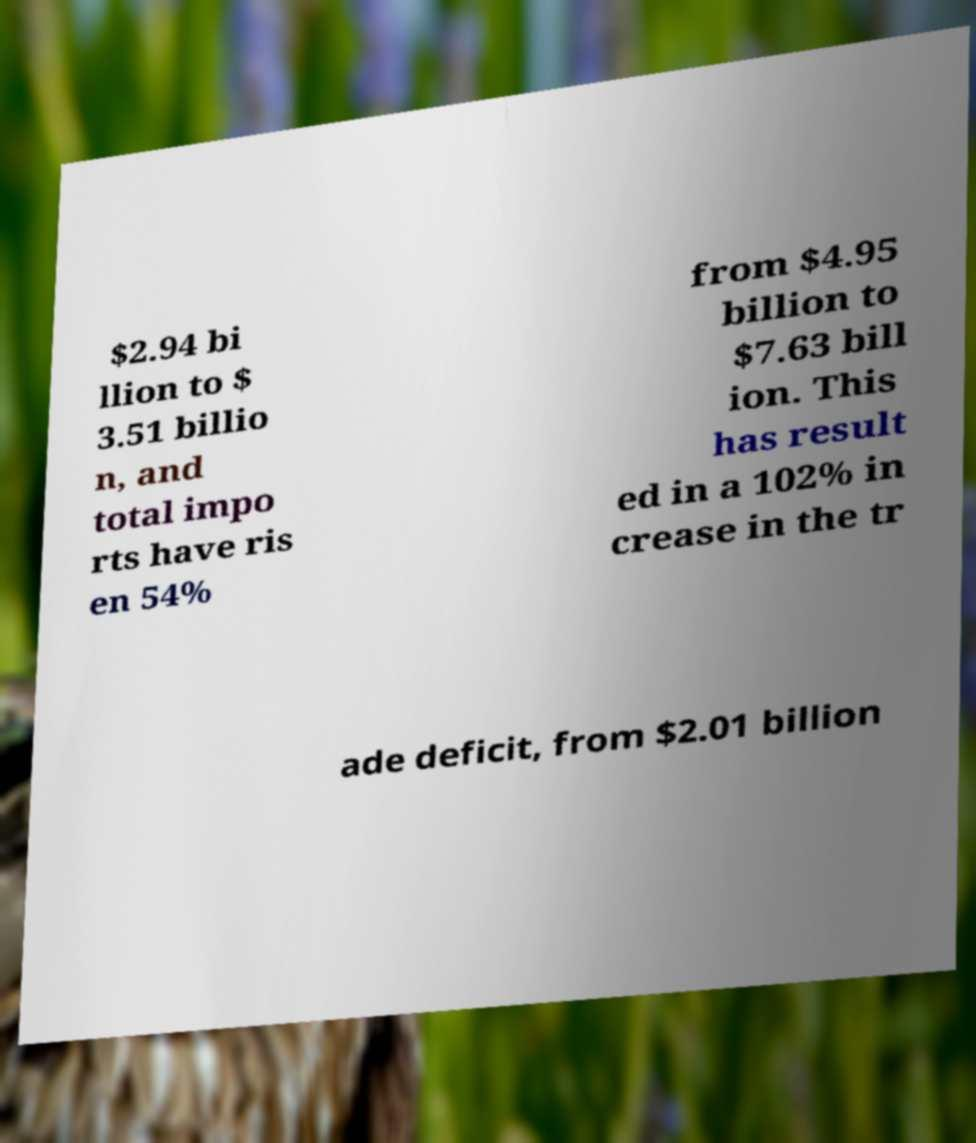Can you read and provide the text displayed in the image?This photo seems to have some interesting text. Can you extract and type it out for me? $2.94 bi llion to $ 3.51 billio n, and total impo rts have ris en 54% from $4.95 billion to $7.63 bill ion. This has result ed in a 102% in crease in the tr ade deficit, from $2.01 billion 